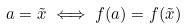Convert formula to latex. <formula><loc_0><loc_0><loc_500><loc_500>a = \tilde { x } \iff f ( a ) = f ( \tilde { x } )</formula> 